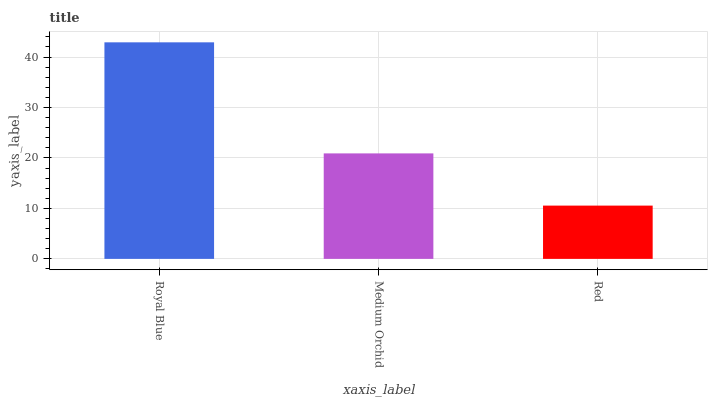Is Red the minimum?
Answer yes or no. Yes. Is Royal Blue the maximum?
Answer yes or no. Yes. Is Medium Orchid the minimum?
Answer yes or no. No. Is Medium Orchid the maximum?
Answer yes or no. No. Is Royal Blue greater than Medium Orchid?
Answer yes or no. Yes. Is Medium Orchid less than Royal Blue?
Answer yes or no. Yes. Is Medium Orchid greater than Royal Blue?
Answer yes or no. No. Is Royal Blue less than Medium Orchid?
Answer yes or no. No. Is Medium Orchid the high median?
Answer yes or no. Yes. Is Medium Orchid the low median?
Answer yes or no. Yes. Is Red the high median?
Answer yes or no. No. Is Royal Blue the low median?
Answer yes or no. No. 